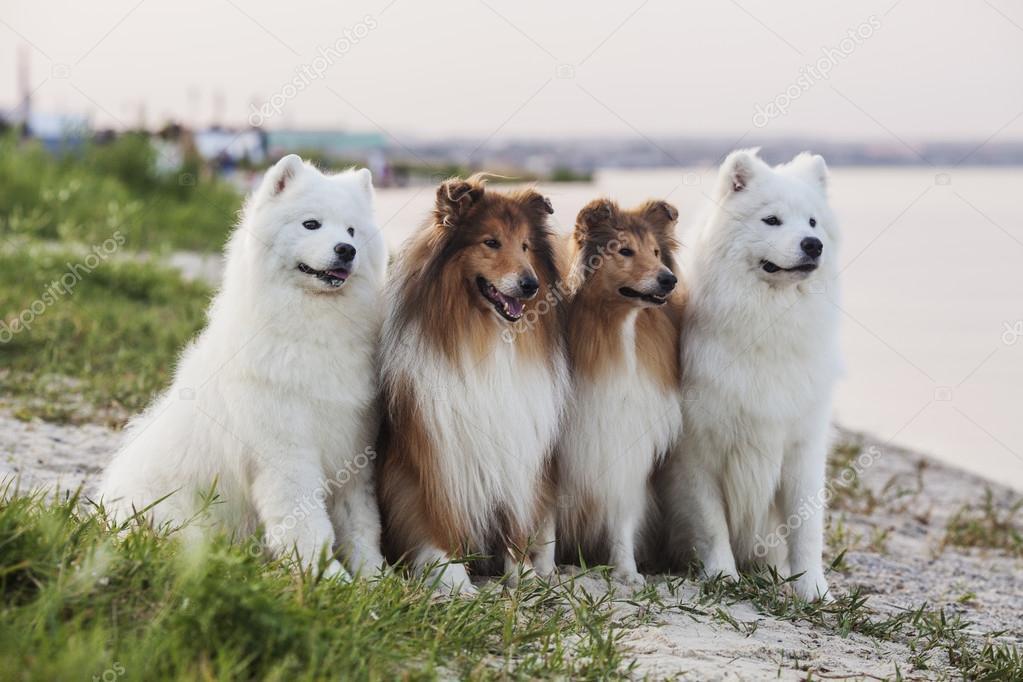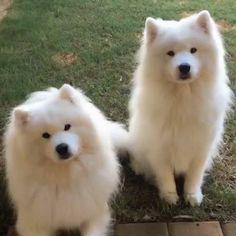The first image is the image on the left, the second image is the image on the right. For the images shown, is this caption "One of the images has two brown and white dogs in between two white dogs." true? Answer yes or no. Yes. The first image is the image on the left, the second image is the image on the right. Evaluate the accuracy of this statement regarding the images: "One image shows two white dogs sitting upright side-by-side, and the other image shows two sitting collies flanked by two sitting white dogs.". Is it true? Answer yes or no. Yes. 